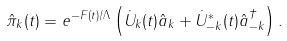Convert formula to latex. <formula><loc_0><loc_0><loc_500><loc_500>\hat { \pi } _ { k } ( t ) = e ^ { - F ( t ) / \Lambda } \left ( \dot { U } _ { k } ( t ) \hat { a } _ { k } + \dot { U } ^ { * } _ { - k } ( t ) \hat { a } ^ { \dagger } _ { - k } \right ) .</formula> 